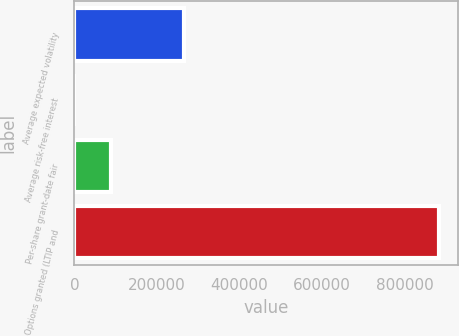Convert chart. <chart><loc_0><loc_0><loc_500><loc_500><bar_chart><fcel>Average expected volatility<fcel>Average risk-free interest<fcel>Per-share grant-date fair<fcel>Options granted (LTIP and<nl><fcel>265412<fcel>3.42<fcel>88473.1<fcel>884700<nl></chart> 